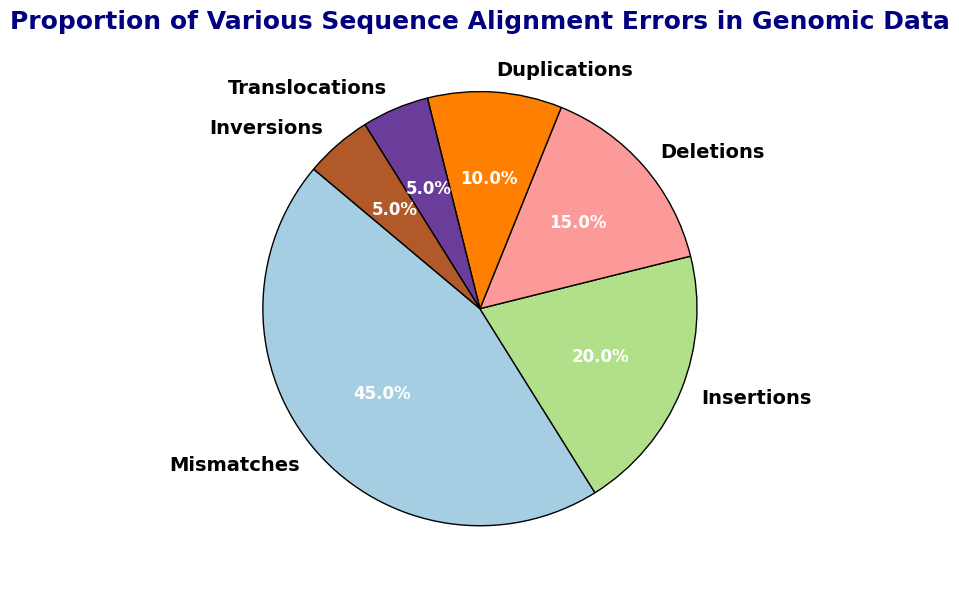What is the proportion of Mismatches in the genomic data? The pie chart indicates that the proportion of Mismatches is labeled as 45.0%.
Answer: 45.0% Which sequence alignment error type has the smallest proportion? By examining the pie chart, we can see that both Translocations and Inversions have the smallest proportion, each with 5.0%.
Answer: Translocations and Inversions How much larger is the proportion of Mismatches compared to Insertions? The proportion of Mismatches is 45.0%, and the proportion of Insertions is 20.0%. The difference is 45.0% - 20.0% = 25.0%.
Answer: 25.0% What is the combined proportion of Deletions and Duplications? Adding the proportions of Deletions (15.0%) and Duplications (10.0%) gives us a combined proportion of 15.0% + 10.0% = 25.0%.
Answer: 25.0% Which error type has a larger proportion: Deletions or Insertions? The pie chart shows Deletions with 15.0% and Insertions with 20.0%, indicating that Insertions have a larger proportion.
Answer: Insertions How does the proportion of Mismatches compare to the sum of Translocations and Inversions? Mismatches have a proportion of 45.0%. The sum of Translocations (5.0%) and Inversions (5.0%) is 5.0% + 5.0% = 10.0%. Therefore, Mismatches proportion is 45.0% - 10.0% = 35.0% higher.
Answer: 35.0% higher Which error types together make up 30% of the total proportion? From the pie chart, the sum of Insertions (20.0%) and Deletions (15.0%) equals 20.0% + 15.0% = 35.0%, but the sum of Insertions (20.0%) and Duplications (10.0%) equals 20.0% + 10.0% = 30.0%.
Answer: Insertions and Duplications What is the difference in proportion between the most frequent and least frequent error types? The most frequent error type is Mismatches with 45.0%, and the least frequent error types are Translocations and Inversions each with 5.0%. The difference is 45.0% - 5.0% = 40.0%.
Answer: 40.0% If the total proportion is 100%, what proportion is attributed to non-Mismatch errors? The proportion of Mismatches is 45.0%. Non-Mismatch errors would be the remaining proportion, which is 100% - 45.0% = 55%.
Answer: 55% 